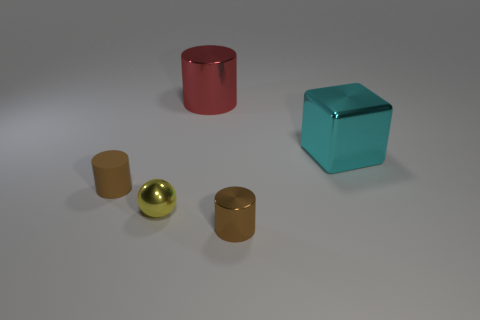There is a matte object; does it have the same color as the thing that is behind the big cube?
Your answer should be very brief. No. What number of things are either things that are left of the cyan metallic cube or objects in front of the big red cylinder?
Provide a succinct answer. 5. Is the number of tiny rubber cylinders in front of the cyan thing greater than the number of small spheres to the right of the red cylinder?
Offer a very short reply. Yes. What material is the tiny cylinder that is to the right of the big red metal thing that is behind the metallic thing in front of the yellow thing made of?
Ensure brevity in your answer.  Metal. There is a small metal thing that is in front of the yellow sphere; is it the same shape as the large cyan metal thing behind the yellow thing?
Provide a short and direct response. No. Is there a metal cylinder of the same size as the brown matte thing?
Your response must be concise. Yes. How many cyan objects are either metallic objects or spheres?
Give a very brief answer. 1. How many small cylinders have the same color as the ball?
Make the answer very short. 0. Is there anything else that is the same shape as the matte thing?
Offer a terse response. Yes. What number of balls are either large red metal things or metallic objects?
Provide a short and direct response. 1. 